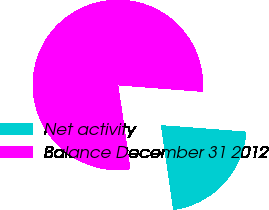<chart> <loc_0><loc_0><loc_500><loc_500><pie_chart><fcel>Net activity<fcel>Balance December 31 2012<nl><fcel>21.49%<fcel>78.51%<nl></chart> 